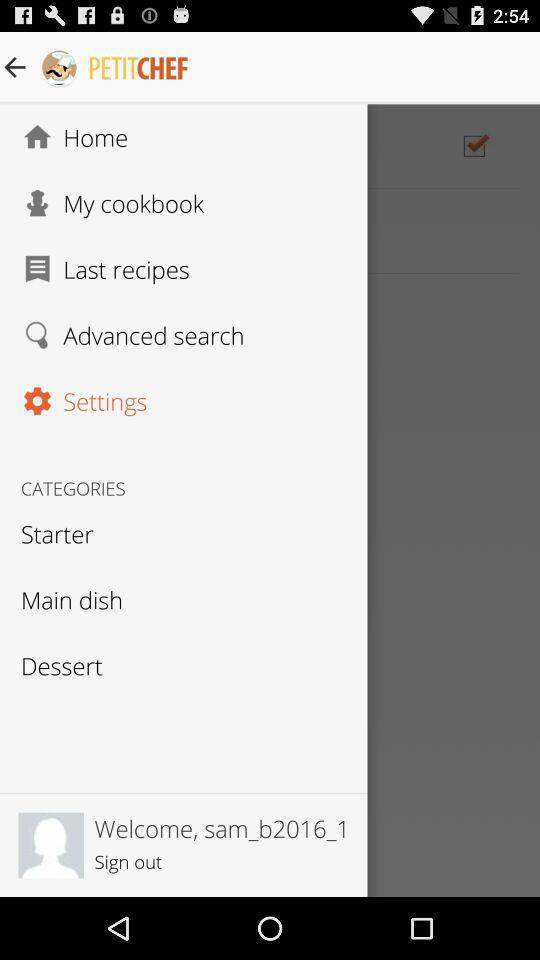What is the name of the user? The name of the user is "sam_b2016_1". 